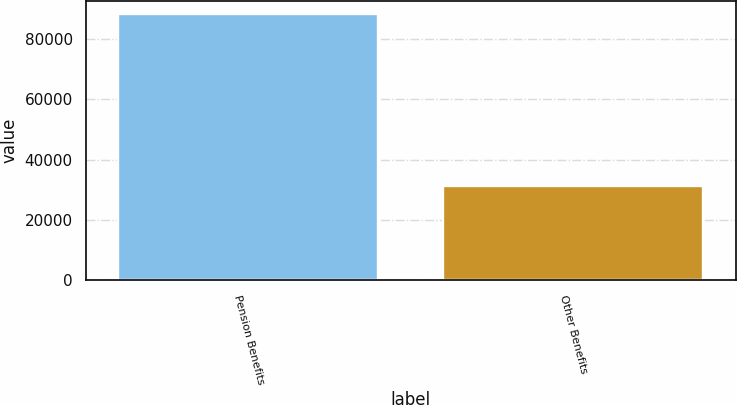Convert chart. <chart><loc_0><loc_0><loc_500><loc_500><bar_chart><fcel>Pension Benefits<fcel>Other Benefits<nl><fcel>88271<fcel>31368<nl></chart> 